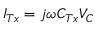Convert formula to latex. <formula><loc_0><loc_0><loc_500><loc_500>{ I _ { T x } } = j \omega { C _ { T x } } { V _ { C } }</formula> 